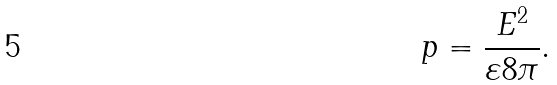Convert formula to latex. <formula><loc_0><loc_0><loc_500><loc_500>p = \frac { E ^ { 2 } } { \varepsilon 8 \pi } .</formula> 